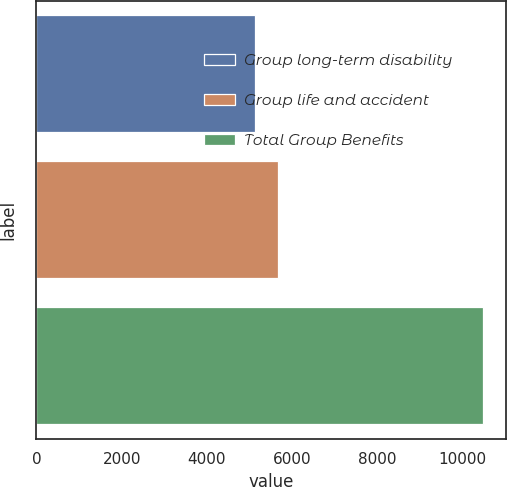Convert chart to OTSL. <chart><loc_0><loc_0><loc_500><loc_500><bar_chart><fcel>Group long-term disability<fcel>Group life and accident<fcel>Total Group Benefits<nl><fcel>5138<fcel>5673<fcel>10488<nl></chart> 